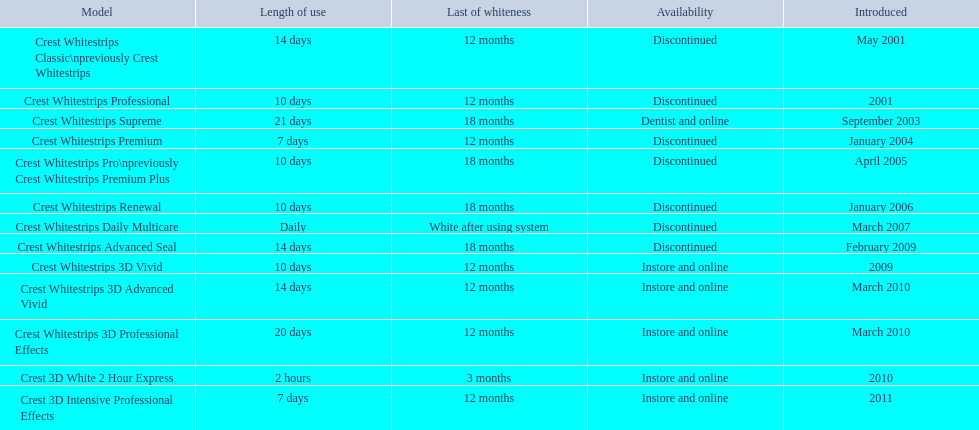Write the full table. {'header': ['Model', 'Length of use', 'Last of whiteness', 'Availability', 'Introduced'], 'rows': [['Crest Whitestrips Classic\\npreviously Crest Whitestrips', '14 days', '12 months', 'Discontinued', 'May 2001'], ['Crest Whitestrips Professional', '10 days', '12 months', 'Discontinued', '2001'], ['Crest Whitestrips Supreme', '21 days', '18 months', 'Dentist and online', 'September 2003'], ['Crest Whitestrips Premium', '7 days', '12 months', 'Discontinued', 'January 2004'], ['Crest Whitestrips Pro\\npreviously Crest Whitestrips Premium Plus', '10 days', '18 months', 'Discontinued', 'April 2005'], ['Crest Whitestrips Renewal', '10 days', '18 months', 'Discontinued', 'January 2006'], ['Crest Whitestrips Daily Multicare', 'Daily', 'White after using system', 'Discontinued', 'March 2007'], ['Crest Whitestrips Advanced Seal', '14 days', '18 months', 'Discontinued', 'February 2009'], ['Crest Whitestrips 3D Vivid', '10 days', '12 months', 'Instore and online', '2009'], ['Crest Whitestrips 3D Advanced Vivid', '14 days', '12 months', 'Instore and online', 'March 2010'], ['Crest Whitestrips 3D Professional Effects', '20 days', '12 months', 'Instore and online', 'March 2010'], ['Crest 3D White 2 Hour Express', '2 hours', '3 months', 'Instore and online', '2010'], ['Crest 3D Intensive Professional Effects', '7 days', '12 months', 'Instore and online', '2011']]} Tell me the number of products that give you 12 months of whiteness. 7. 